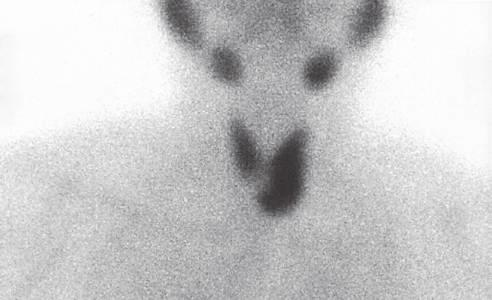s preoperative scintigraphy useful in localizing and distinguishing adenomas from parathyroid hyperplasia, in which more than one gland will demonstrate increased uptake?
Answer the question using a single word or phrase. Yes 